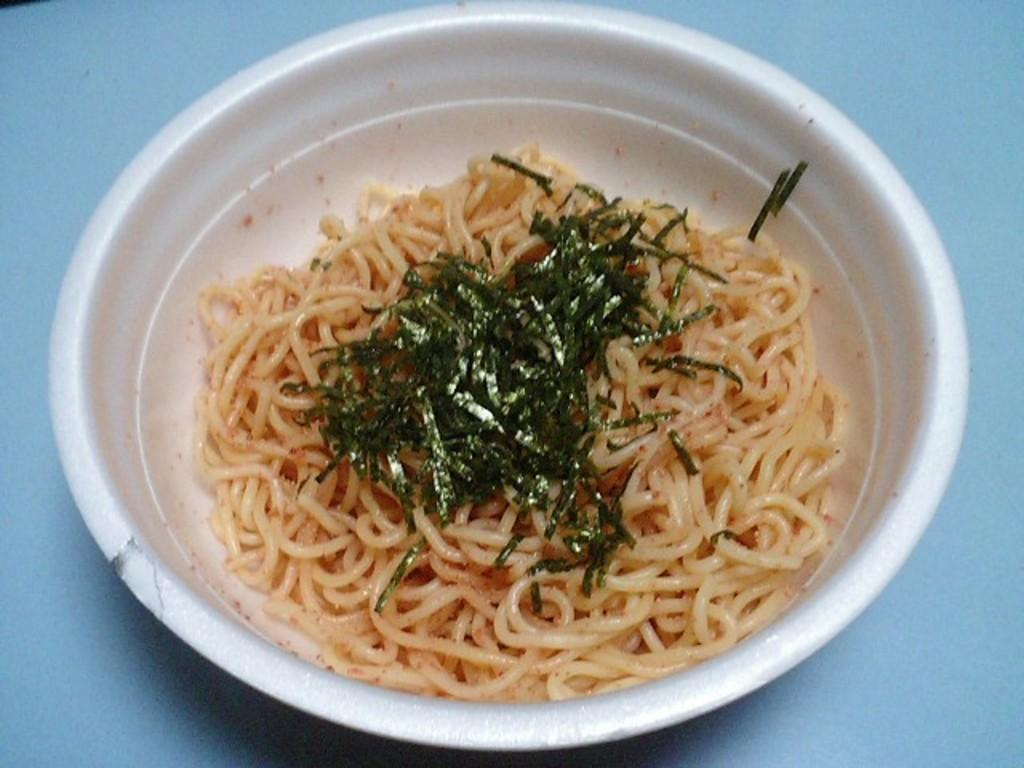What is in the bowl that is visible in the image? The bowl contains noodles and leafy vegetables. Where is the bowl located in the image? The bowl is placed on a table. What type of food is in the bowl? The bowl contains noodles and leafy vegetables, which suggests it might be a noodle dish with vegetables. What type of milk is being whipped by the family in the image? There is no milk or family present in the image; it features a bowl of noodles and leafy vegetables on a table. 